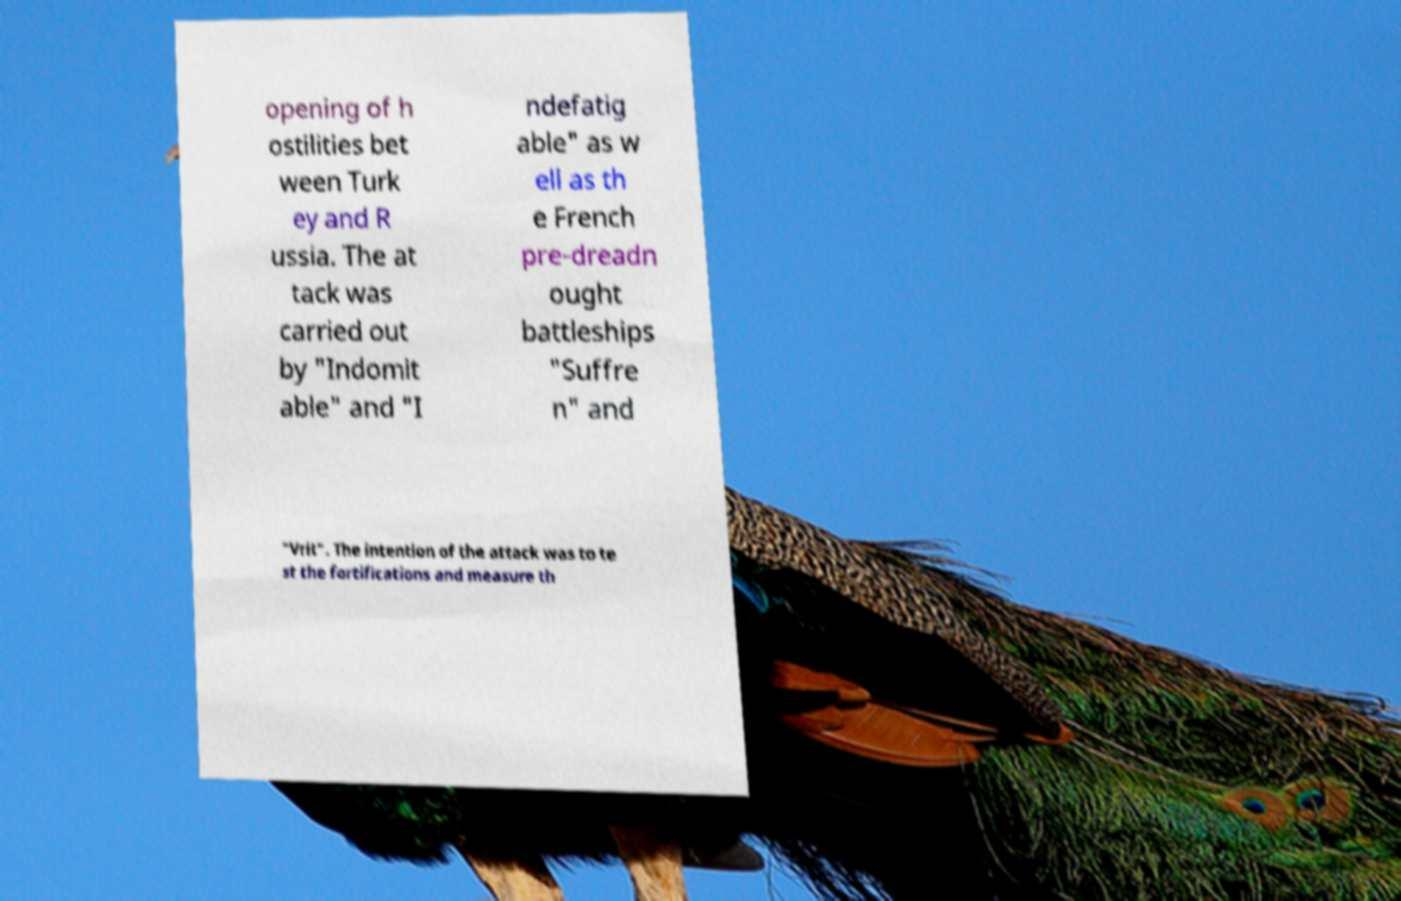What messages or text are displayed in this image? I need them in a readable, typed format. opening of h ostilities bet ween Turk ey and R ussia. The at tack was carried out by "Indomit able" and "I ndefatig able" as w ell as th e French pre-dreadn ought battleships "Suffre n" and "Vrit". The intention of the attack was to te st the fortifications and measure th 